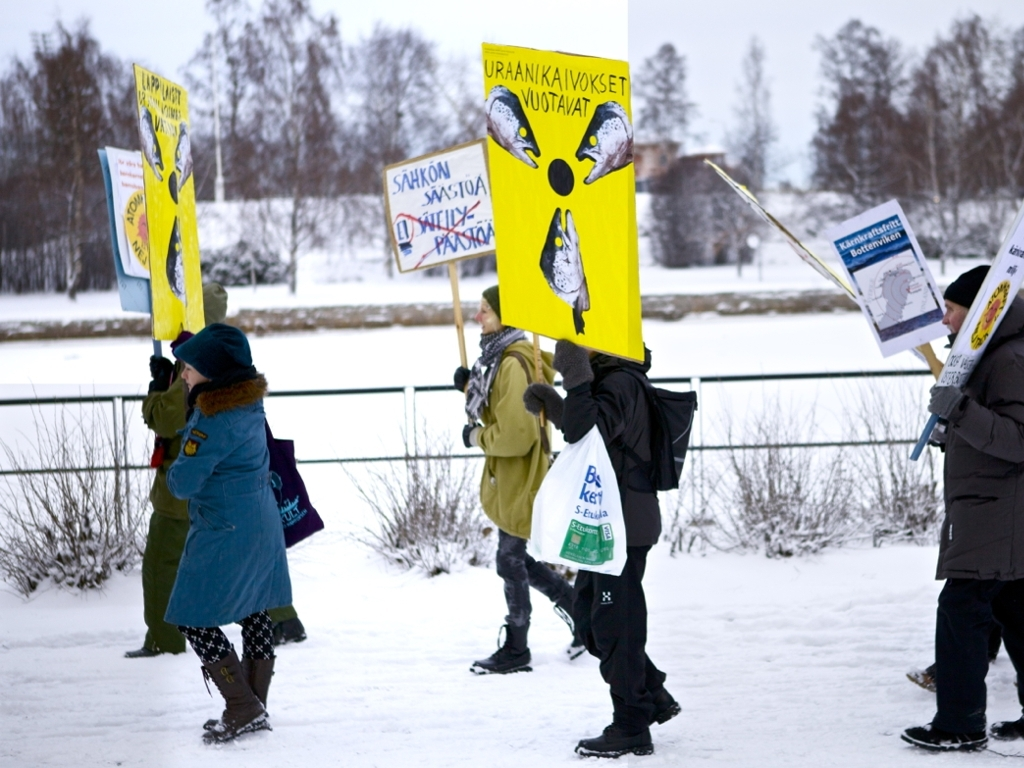How visible are the text and details on the promotional sign?
A. Partially visible
B. Completely invisible
C. Clearly visible
Answer with the option's letter from the given choices directly.
 C. 